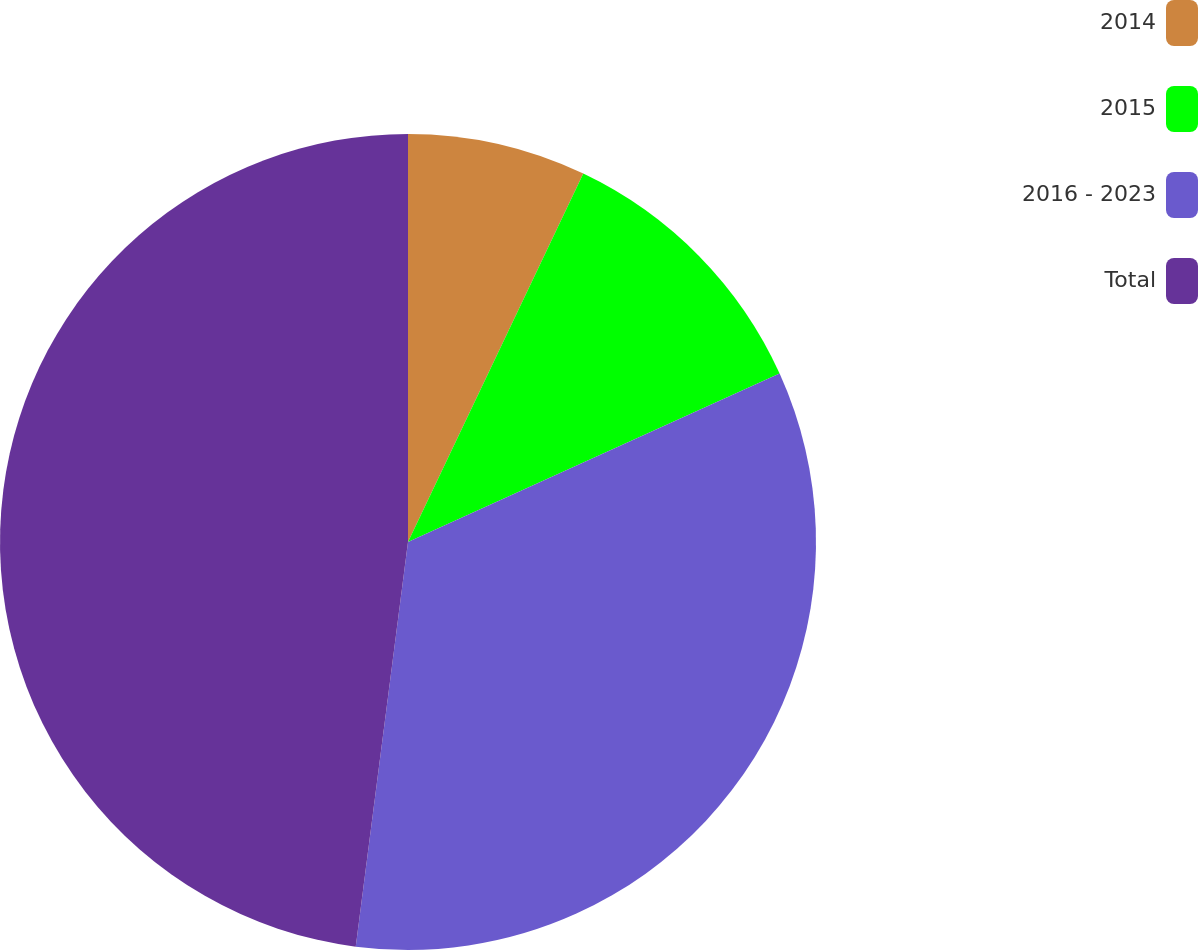Convert chart to OTSL. <chart><loc_0><loc_0><loc_500><loc_500><pie_chart><fcel>2014<fcel>2015<fcel>2016 - 2023<fcel>Total<nl><fcel>7.07%<fcel>11.16%<fcel>33.82%<fcel>47.96%<nl></chart> 